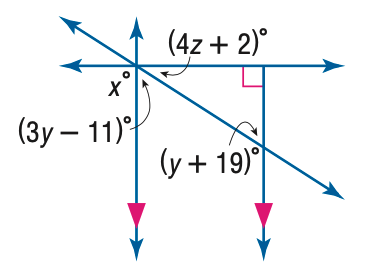Answer the mathemtical geometry problem and directly provide the correct option letter.
Question: Find x in the figure.
Choices: A: 13.5 B: 15 C: 90 D: 180 C 